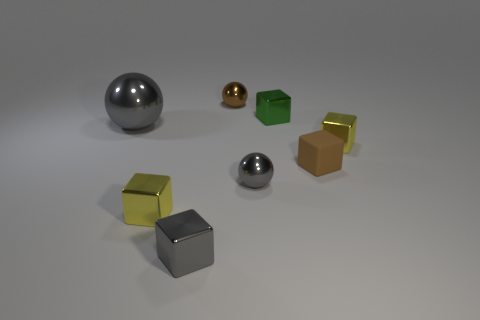Subtract all brown cubes. How many cubes are left? 4 Subtract all rubber blocks. How many blocks are left? 4 Subtract all cyan cubes. Subtract all green balls. How many cubes are left? 5 Add 2 cyan metallic blocks. How many objects exist? 10 Subtract all balls. How many objects are left? 5 Add 1 gray shiny objects. How many gray shiny objects exist? 4 Subtract 0 green spheres. How many objects are left? 8 Subtract all cyan metal blocks. Subtract all tiny metallic objects. How many objects are left? 2 Add 5 big gray metallic balls. How many big gray metallic balls are left? 6 